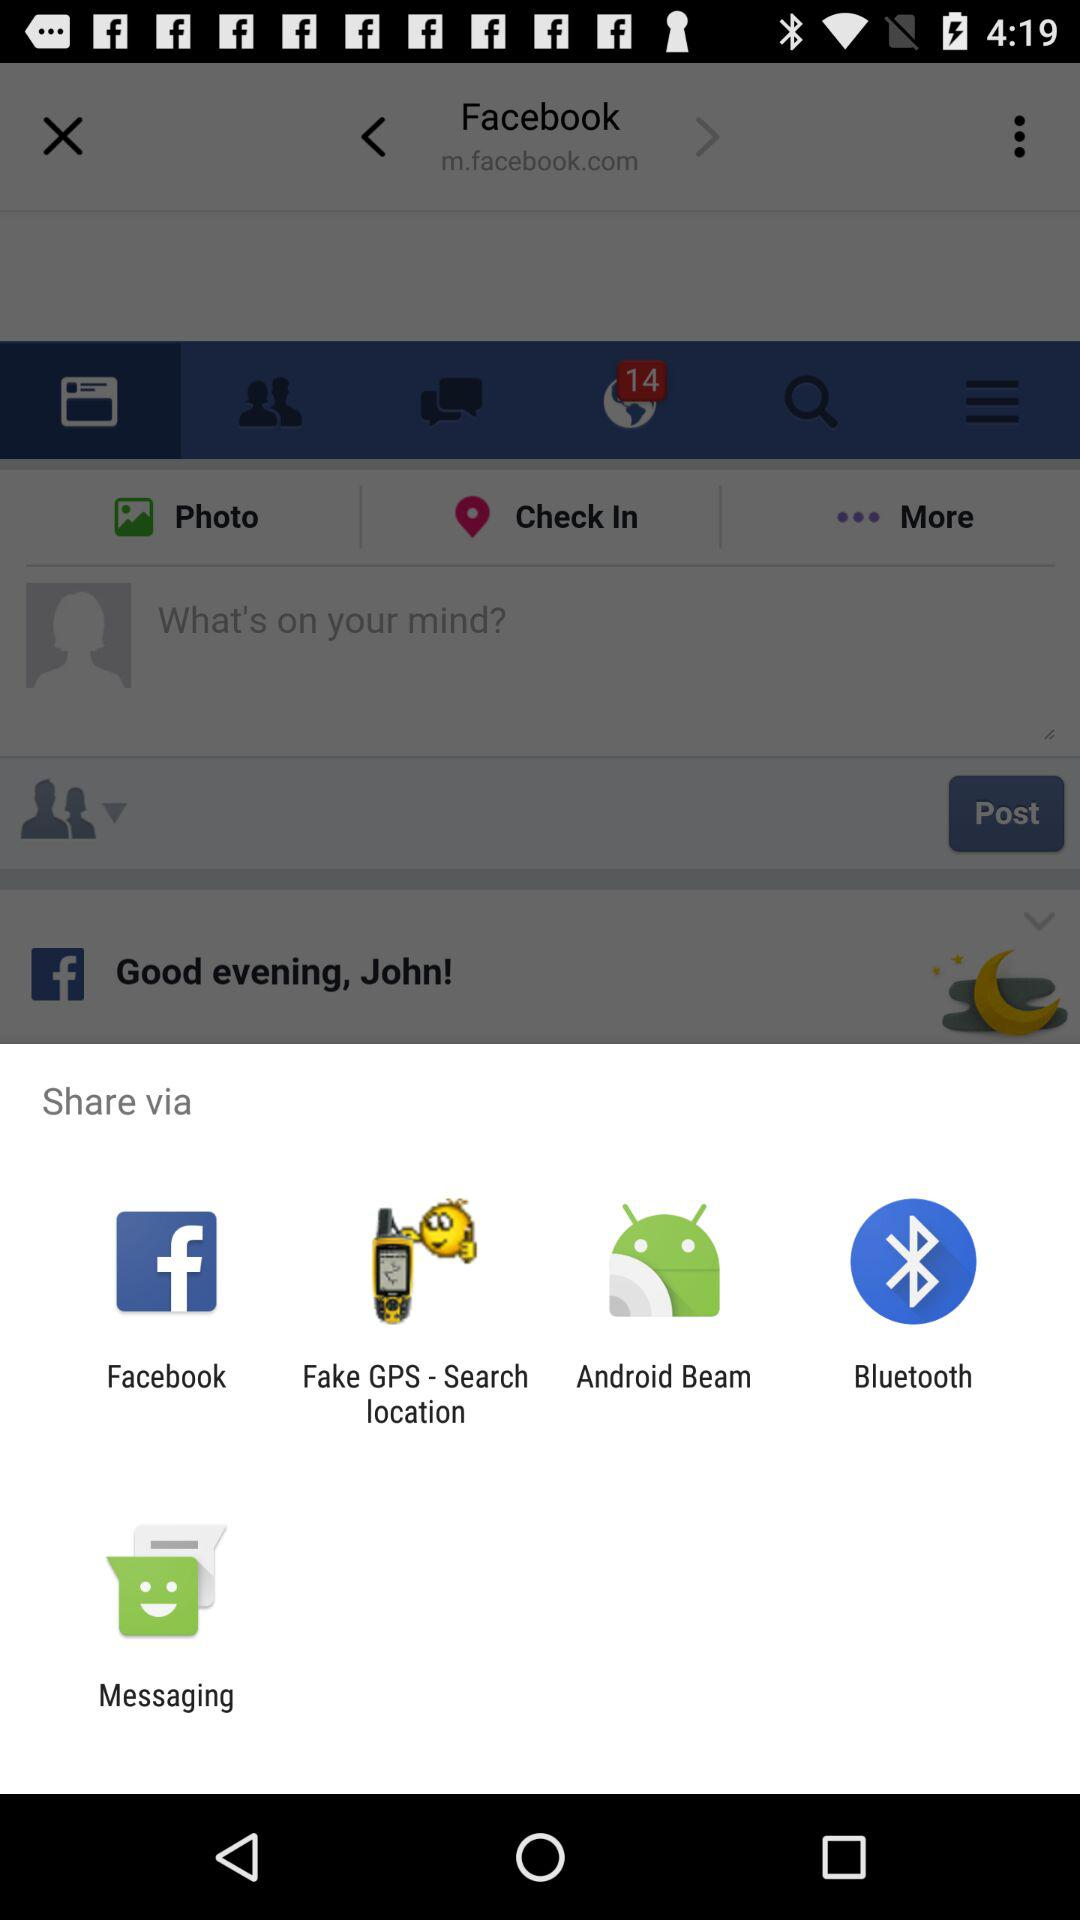Through which applications can the content be shared? The content can be shared through "Facebook", "Fake GPS - Search location", "Android Beam", "Bluetooth" and "Messaging". 